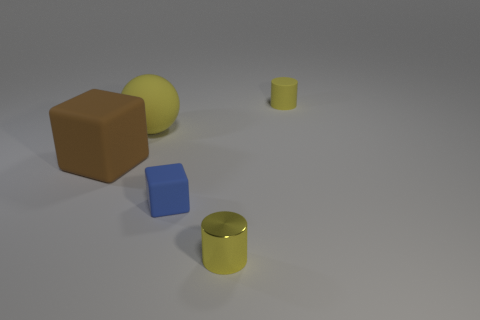What size is the matte cylinder that is the same color as the tiny metallic cylinder?
Offer a terse response. Small. What shape is the large rubber thing that is the same color as the metal thing?
Provide a succinct answer. Sphere. How big is the yellow cylinder that is in front of the yellow thing that is right of the small yellow object that is in front of the small cube?
Ensure brevity in your answer.  Small. What is the tiny blue cube made of?
Offer a terse response. Rubber. Do the yellow sphere and the small yellow cylinder behind the brown matte block have the same material?
Make the answer very short. Yes. Is there anything else of the same color as the tiny matte block?
Offer a terse response. No. There is a small rubber thing left of the tiny object that is behind the sphere; are there any blue matte blocks on the right side of it?
Ensure brevity in your answer.  No. The rubber ball is what color?
Your answer should be very brief. Yellow. Are there any small shiny cylinders in front of the brown matte block?
Ensure brevity in your answer.  Yes. Is the shape of the tiny yellow rubber object the same as the yellow object in front of the small blue object?
Keep it short and to the point. Yes. 